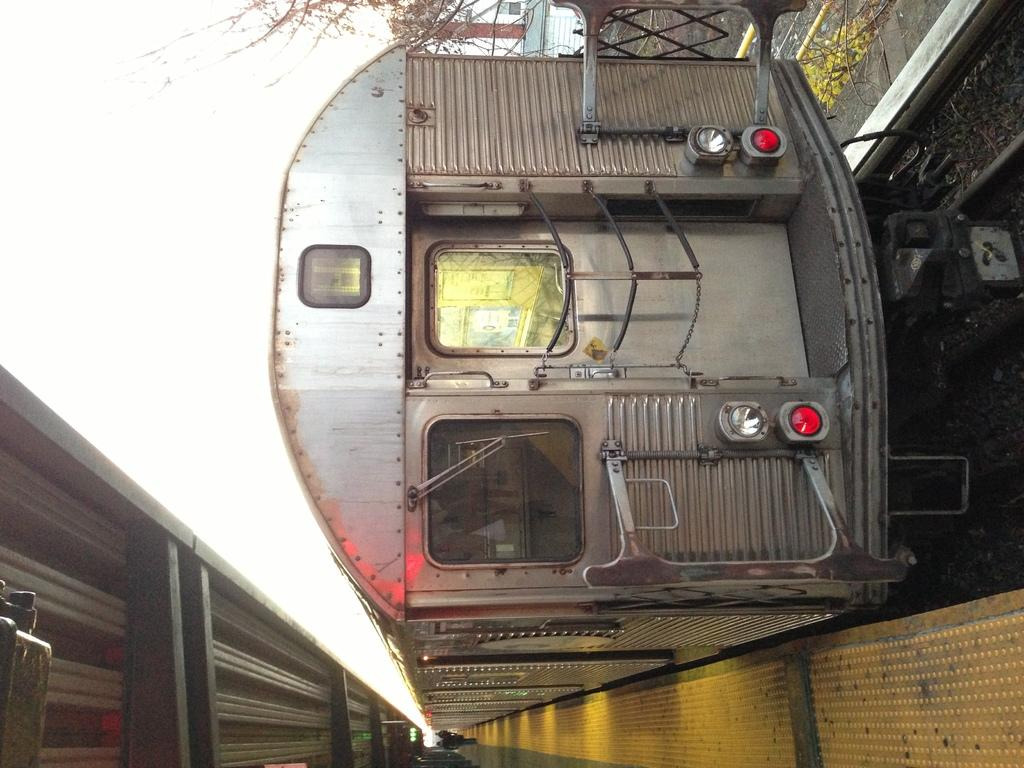What is the main subject of the image? The main subject of the image is a train. Where is the train located in the image? The train is on a track in the image. What can be seen in the background of the image? There are trees visible in the image. Are there any people present in the image? Yes, there are people in the image. What type of health advice can be seen on the train in the image? There is no health advice present on the train in the image. Can you tell me how many goldfish are swimming in the water near the train? There are no goldfish or water visible in the image; it features a train on a track with trees in the background and people nearby. 